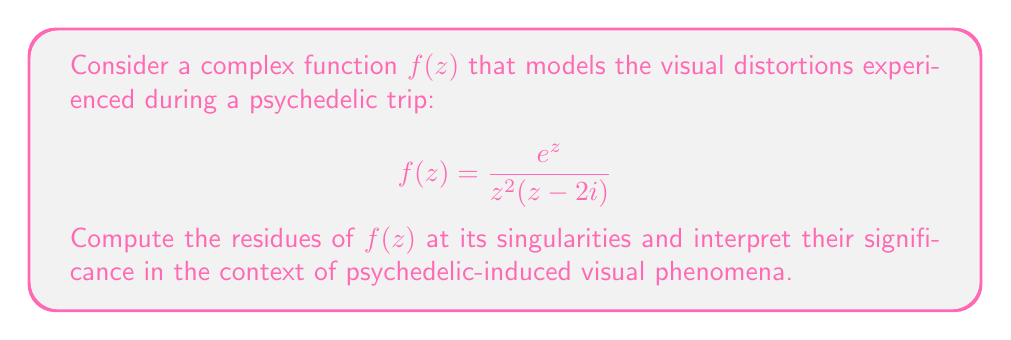Could you help me with this problem? To compute the residues of $f(z)$, we need to identify its singularities and analyze them:

1. Singularities:
   - $z = 0$ (double pole)
   - $z = 2i$ (simple pole)

2. Residue at $z = 0$ (double pole):
   For a double pole, we use the formula:
   $$\text{Res}(f,0) = \lim_{z \to 0} \frac{d}{dz}\left[z^2f(z)\right]$$
   
   Let $g(z) = z^2f(z) = \frac{e^z}{z-2i}$
   
   $$\begin{align*}
   \text{Res}(f,0) &= \lim_{z \to 0} \frac{d}{dz}\left[\frac{e^z}{z-2i}\right] \\
   &= \lim_{z \to 0} \frac{e^z(z-2i) - e^z}{(z-2i)^2} \\
   &= \lim_{z \to 0} \frac{e^z(z-2i-1)}{(z-2i)^2} \\
   &= \frac{1}{(-2i)^2} = -\frac{1}{4}
   \end{align*}$$

3. Residue at $z = 2i$ (simple pole):
   For a simple pole, we use the formula:
   $$\text{Res}(f,2i) = \lim_{z \to 2i} (z-2i)f(z)$$
   
   $$\begin{align*}
   \text{Res}(f,2i) &= \lim_{z \to 2i} (z-2i)\frac{e^z}{z^2(z-2i)} \\
   &= \lim_{z \to 2i} \frac{e^z}{z^2} \\
   &= \frac{e^{2i}}{(2i)^2} \\
   &= -\frac{1}{4}e^{2i}
   \end{align*}$$

Interpretation:
The residues represent the strength and nature of different visual distortions during a psychedelic experience. The residue at $z = 0$ is real and negative, suggesting a consistent, grounding effect in the visual field. The residue at $z = 2i$ is complex, indicating a more dynamic and oscillatory visual distortion that may manifest as waves or patterns in the visual perception.
Answer: The residues of $f(z) = \frac{e^z}{z^2(z-2i)}$ are:

1. At $z = 0$: $\text{Res}(f,0) = -\frac{1}{4}$
2. At $z = 2i$: $\text{Res}(f,2i) = -\frac{1}{4}e^{2i}$ 